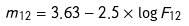Convert formula to latex. <formula><loc_0><loc_0><loc_500><loc_500>m _ { 1 2 } = 3 . 6 3 - 2 . 5 \times \log F _ { 1 2 }</formula> 